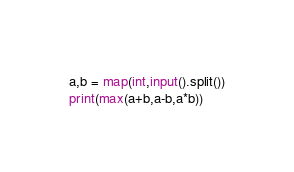<code> <loc_0><loc_0><loc_500><loc_500><_Python_>a,b = map(int,input().split())
print(max(a+b,a-b,a*b))</code> 